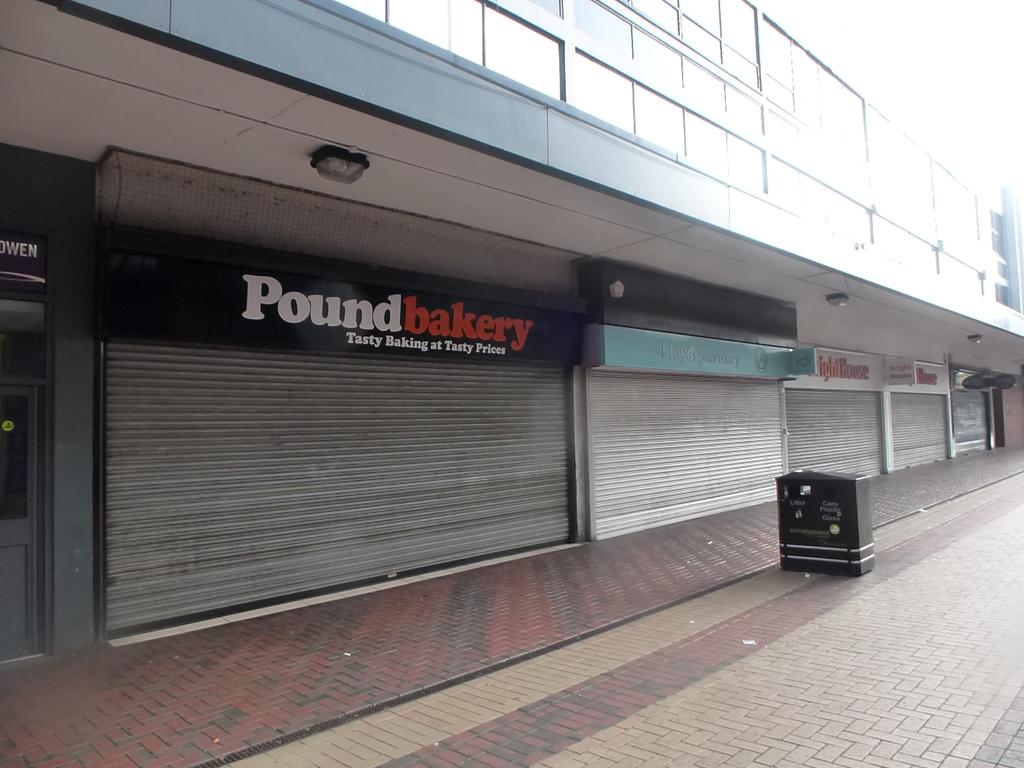What is the name of the bakery?
Your answer should be compact. Poundbakery. Some shopping bulidings?
Offer a very short reply. Not a question. 